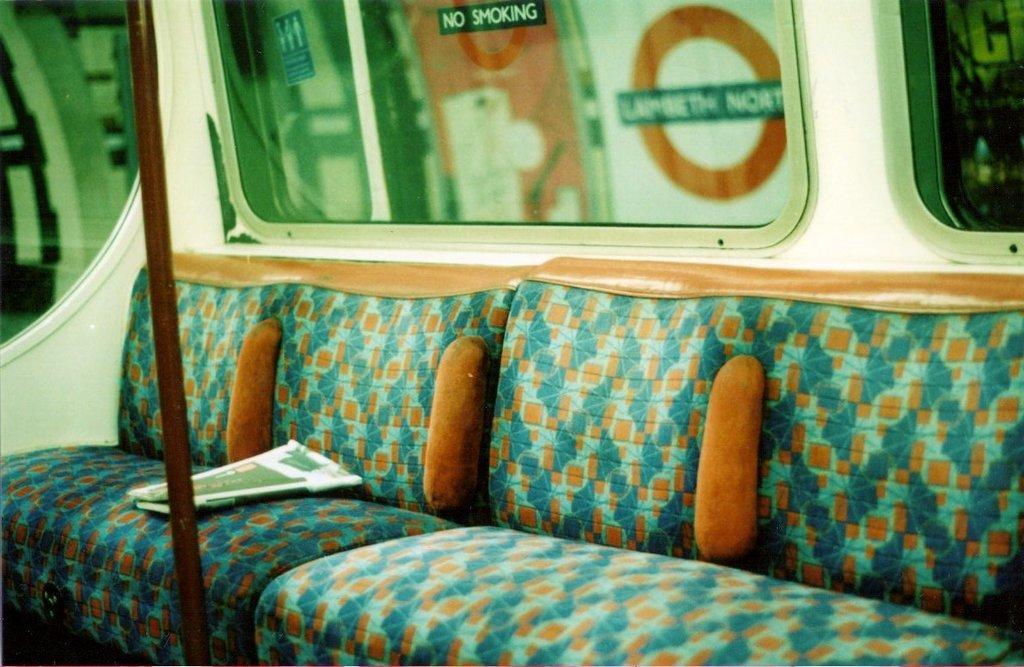How would you summarize this image in a sentence or two? In this image I can see the inner part of the vehicle. I can also see a couch which is in orange and green color, background I can see few windows. 